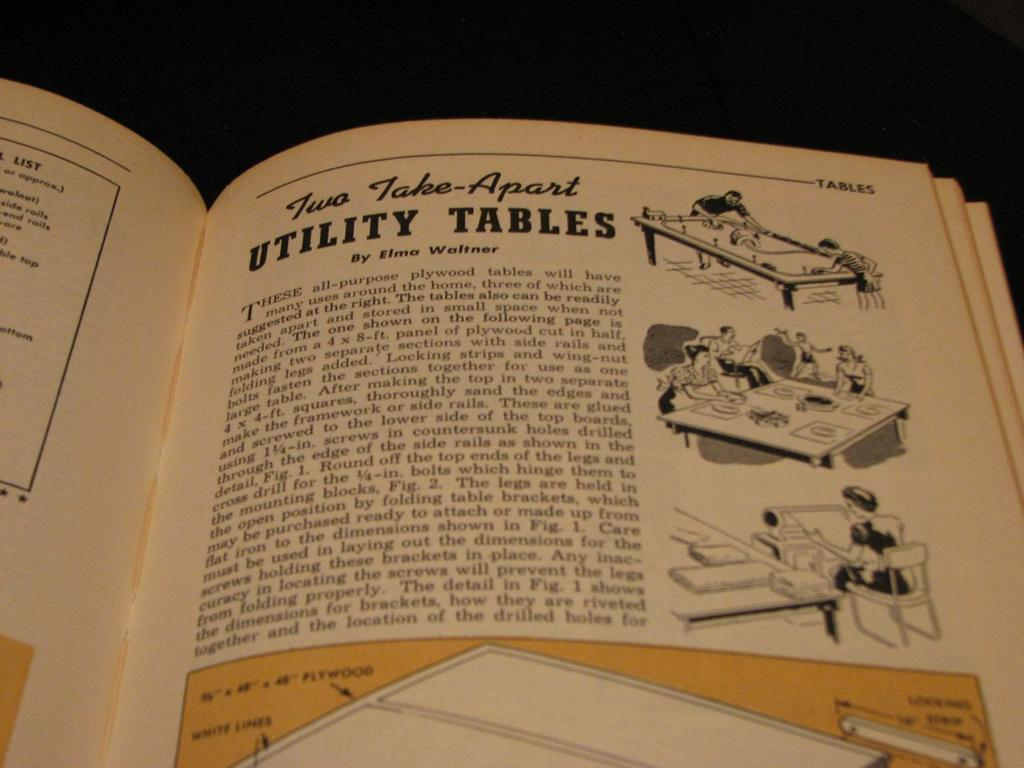<image>
Share a concise interpretation of the image provided. A book is open to a page that says Utility Tables. 